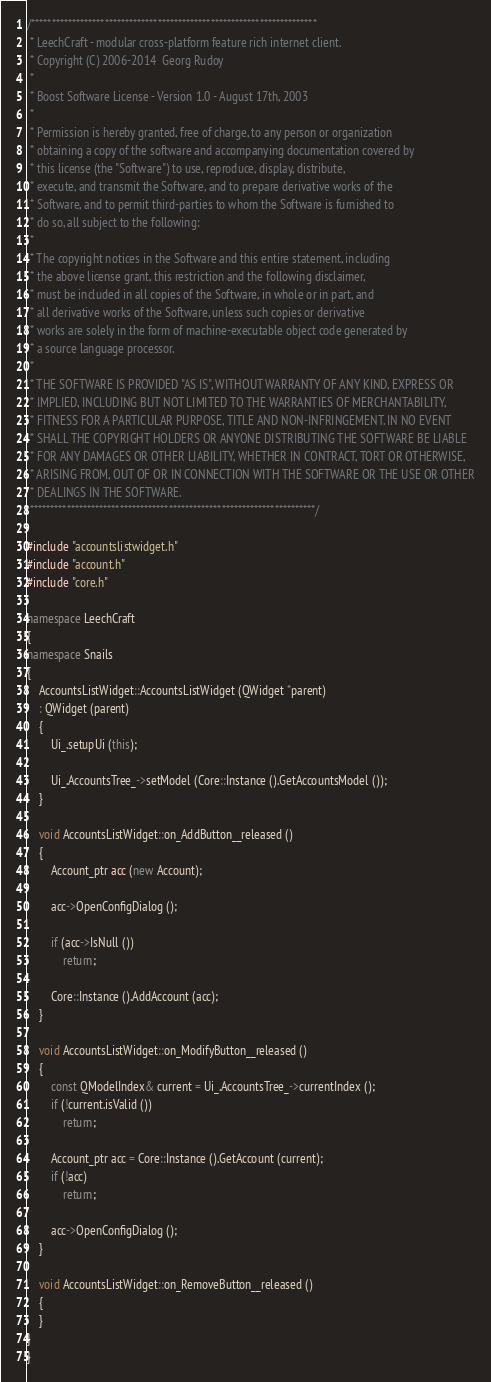<code> <loc_0><loc_0><loc_500><loc_500><_C++_>/**********************************************************************
 * LeechCraft - modular cross-platform feature rich internet client.
 * Copyright (C) 2006-2014  Georg Rudoy
 *
 * Boost Software License - Version 1.0 - August 17th, 2003
 *
 * Permission is hereby granted, free of charge, to any person or organization
 * obtaining a copy of the software and accompanying documentation covered by
 * this license (the "Software") to use, reproduce, display, distribute,
 * execute, and transmit the Software, and to prepare derivative works of the
 * Software, and to permit third-parties to whom the Software is furnished to
 * do so, all subject to the following:
 *
 * The copyright notices in the Software and this entire statement, including
 * the above license grant, this restriction and the following disclaimer,
 * must be included in all copies of the Software, in whole or in part, and
 * all derivative works of the Software, unless such copies or derivative
 * works are solely in the form of machine-executable object code generated by
 * a source language processor.
 *
 * THE SOFTWARE IS PROVIDED "AS IS", WITHOUT WARRANTY OF ANY KIND, EXPRESS OR
 * IMPLIED, INCLUDING BUT NOT LIMITED TO THE WARRANTIES OF MERCHANTABILITY,
 * FITNESS FOR A PARTICULAR PURPOSE, TITLE AND NON-INFRINGEMENT. IN NO EVENT
 * SHALL THE COPYRIGHT HOLDERS OR ANYONE DISTRIBUTING THE SOFTWARE BE LIABLE
 * FOR ANY DAMAGES OR OTHER LIABILITY, WHETHER IN CONTRACT, TORT OR OTHERWISE,
 * ARISING FROM, OUT OF OR IN CONNECTION WITH THE SOFTWARE OR THE USE OR OTHER
 * DEALINGS IN THE SOFTWARE.
 **********************************************************************/

#include "accountslistwidget.h"
#include "account.h"
#include "core.h"

namespace LeechCraft
{
namespace Snails
{
	AccountsListWidget::AccountsListWidget (QWidget *parent)
	: QWidget (parent)
	{
		Ui_.setupUi (this);

		Ui_.AccountsTree_->setModel (Core::Instance ().GetAccountsModel ());
	}

	void AccountsListWidget::on_AddButton__released ()
	{
		Account_ptr acc (new Account);

		acc->OpenConfigDialog ();

		if (acc->IsNull ())
			return;

		Core::Instance ().AddAccount (acc);
	}

	void AccountsListWidget::on_ModifyButton__released ()
	{
		const QModelIndex& current = Ui_.AccountsTree_->currentIndex ();
		if (!current.isValid ())
			return;

		Account_ptr acc = Core::Instance ().GetAccount (current);
		if (!acc)
			return;

		acc->OpenConfigDialog ();
	}

	void AccountsListWidget::on_RemoveButton__released ()
	{
	}
}
}
</code> 